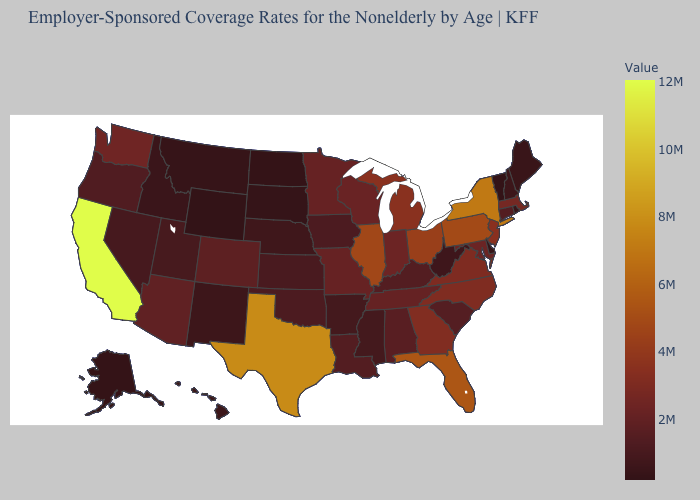Which states hav the highest value in the West?
Keep it brief. California. Which states have the highest value in the USA?
Be succinct. California. Among the states that border Arkansas , does Tennessee have the highest value?
Answer briefly. No. 